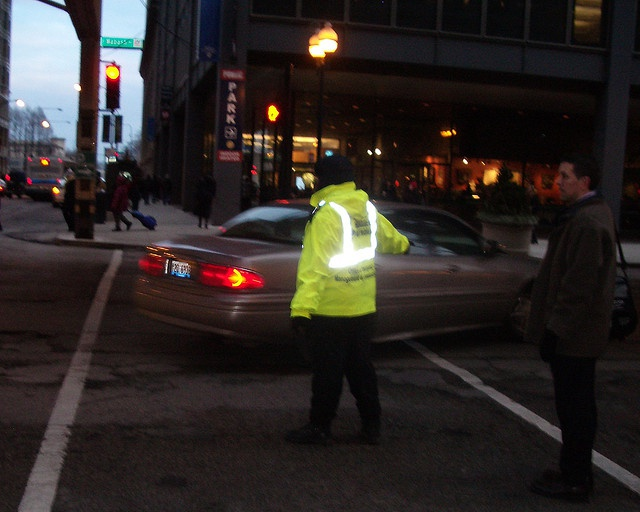Describe the objects in this image and their specific colors. I can see car in black, maroon, gray, and brown tones, people in black, olive, and white tones, people in black, maroon, and purple tones, potted plant in black, maroon, gray, and brown tones, and bus in black and gray tones in this image. 